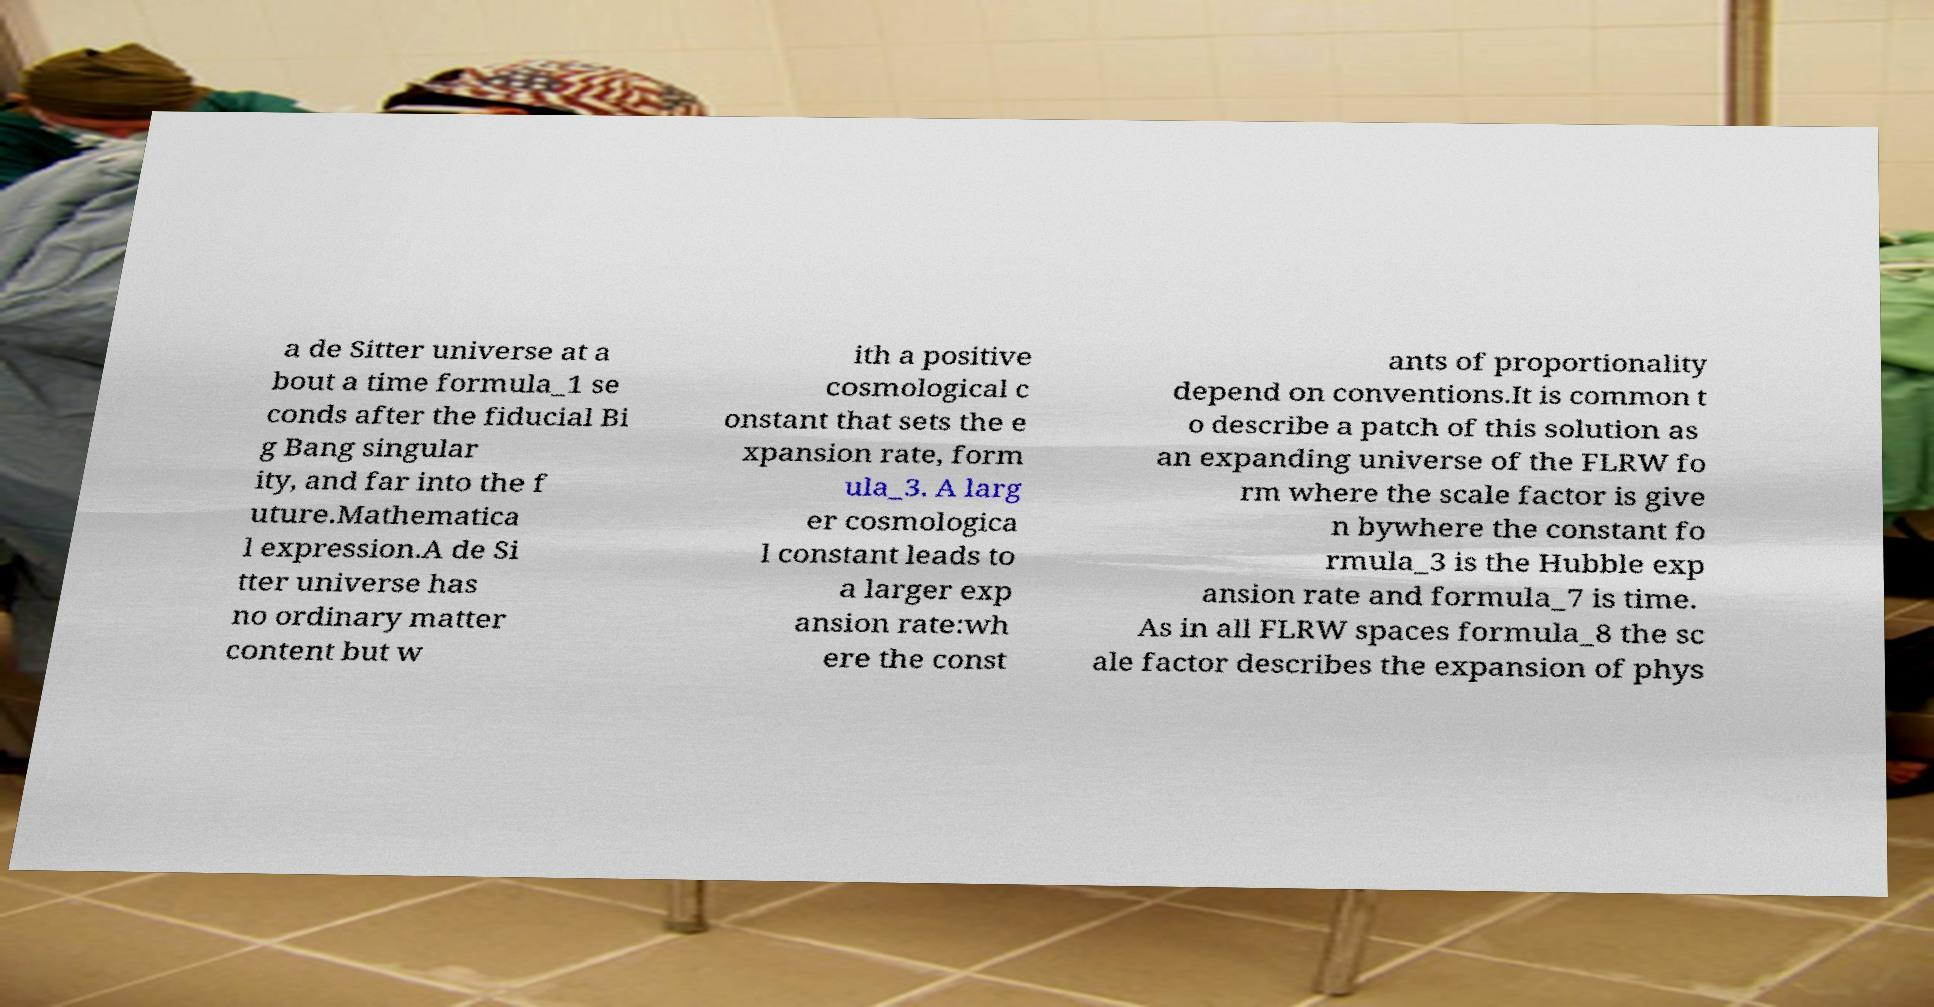I need the written content from this picture converted into text. Can you do that? a de Sitter universe at a bout a time formula_1 se conds after the fiducial Bi g Bang singular ity, and far into the f uture.Mathematica l expression.A de Si tter universe has no ordinary matter content but w ith a positive cosmological c onstant that sets the e xpansion rate, form ula_3. A larg er cosmologica l constant leads to a larger exp ansion rate:wh ere the const ants of proportionality depend on conventions.It is common t o describe a patch of this solution as an expanding universe of the FLRW fo rm where the scale factor is give n bywhere the constant fo rmula_3 is the Hubble exp ansion rate and formula_7 is time. As in all FLRW spaces formula_8 the sc ale factor describes the expansion of phys 